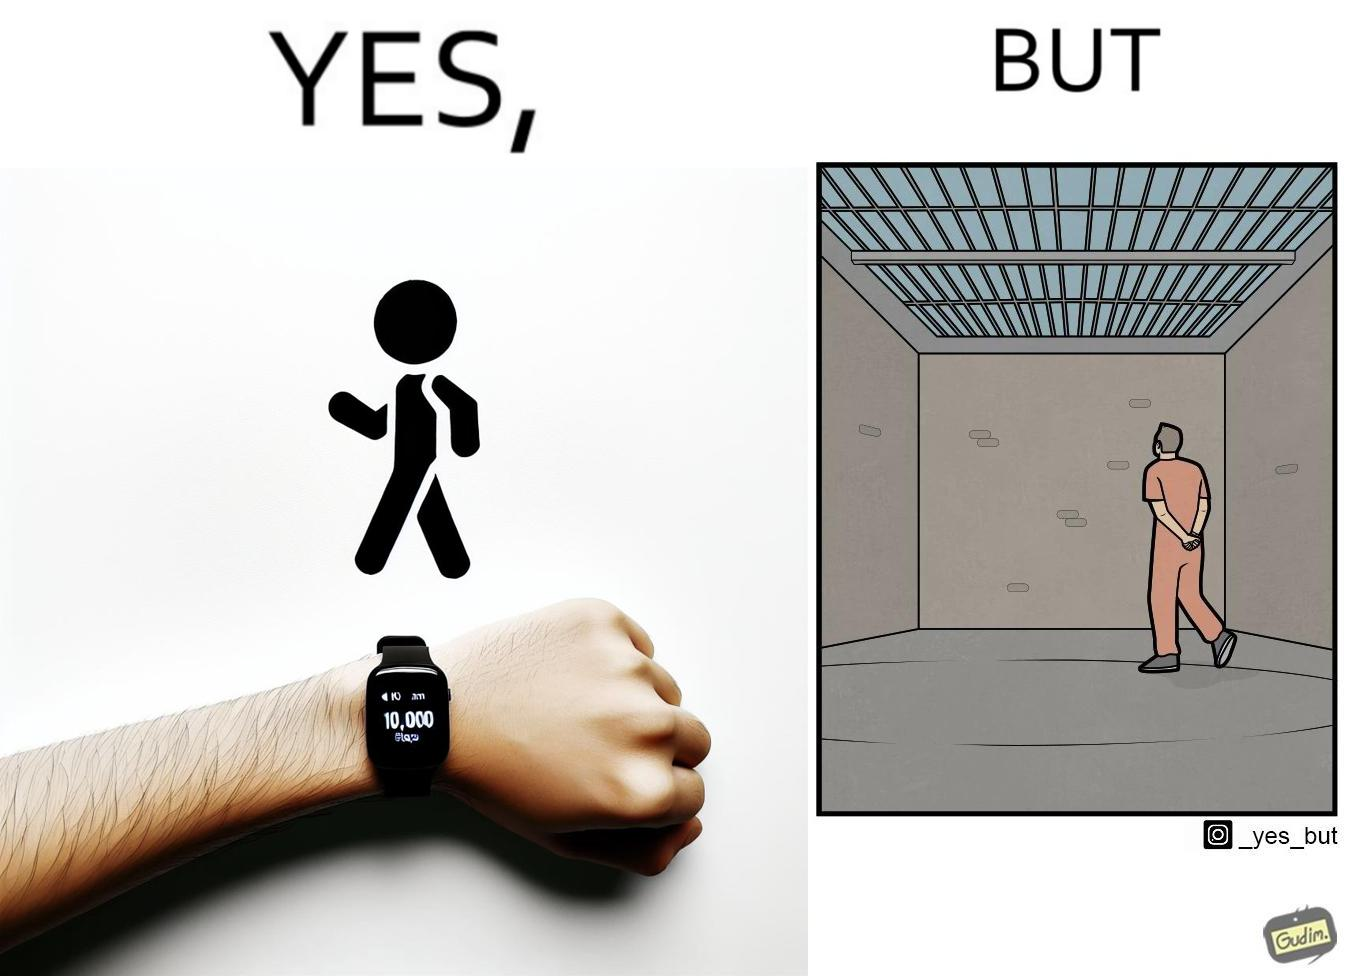Describe the satirical element in this image. The image is ironical, as the smartwatch on the person's wrist shows 10,000 steps completed as an accomplishment, while showing later that the person is apparently walking inside a jail as a prisoner. 